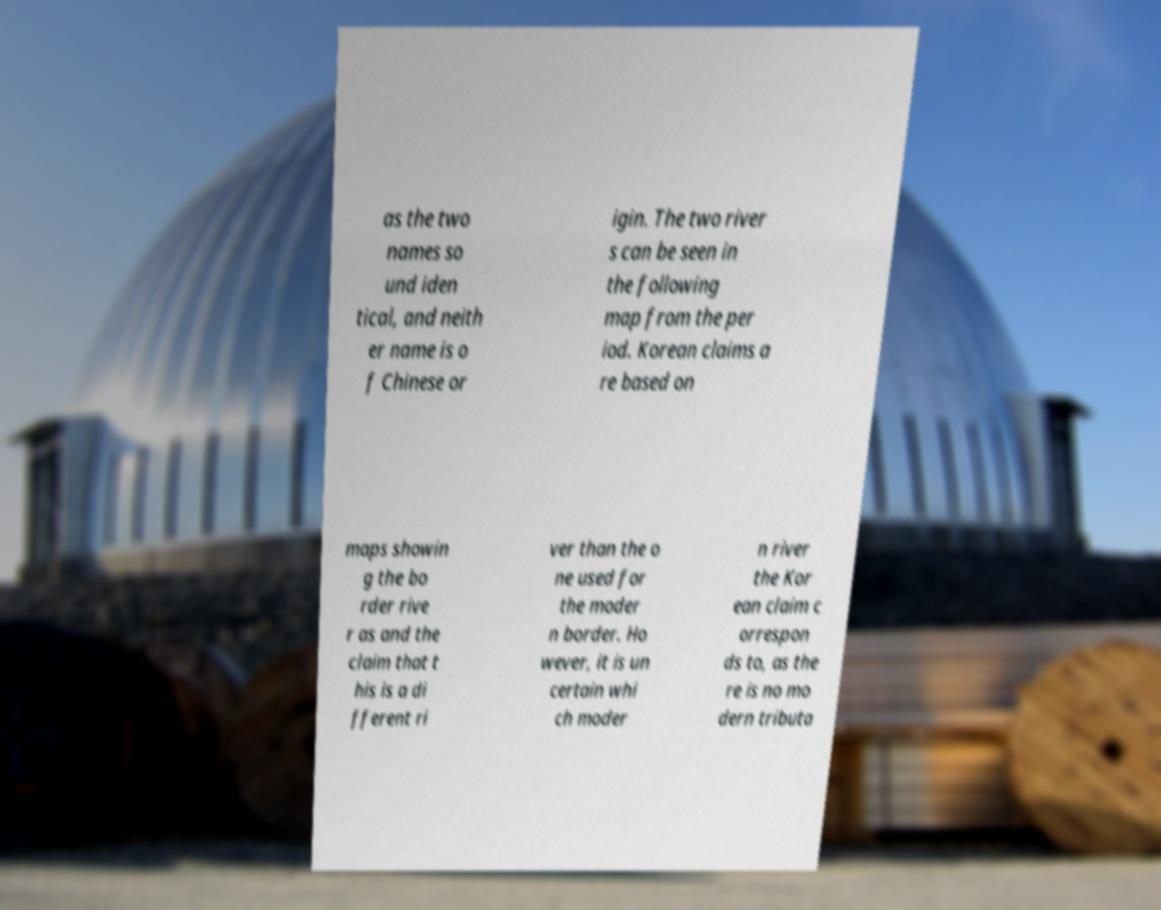Could you assist in decoding the text presented in this image and type it out clearly? as the two names so und iden tical, and neith er name is o f Chinese or igin. The two river s can be seen in the following map from the per iod. Korean claims a re based on maps showin g the bo rder rive r as and the claim that t his is a di fferent ri ver than the o ne used for the moder n border. Ho wever, it is un certain whi ch moder n river the Kor ean claim c orrespon ds to, as the re is no mo dern tributa 